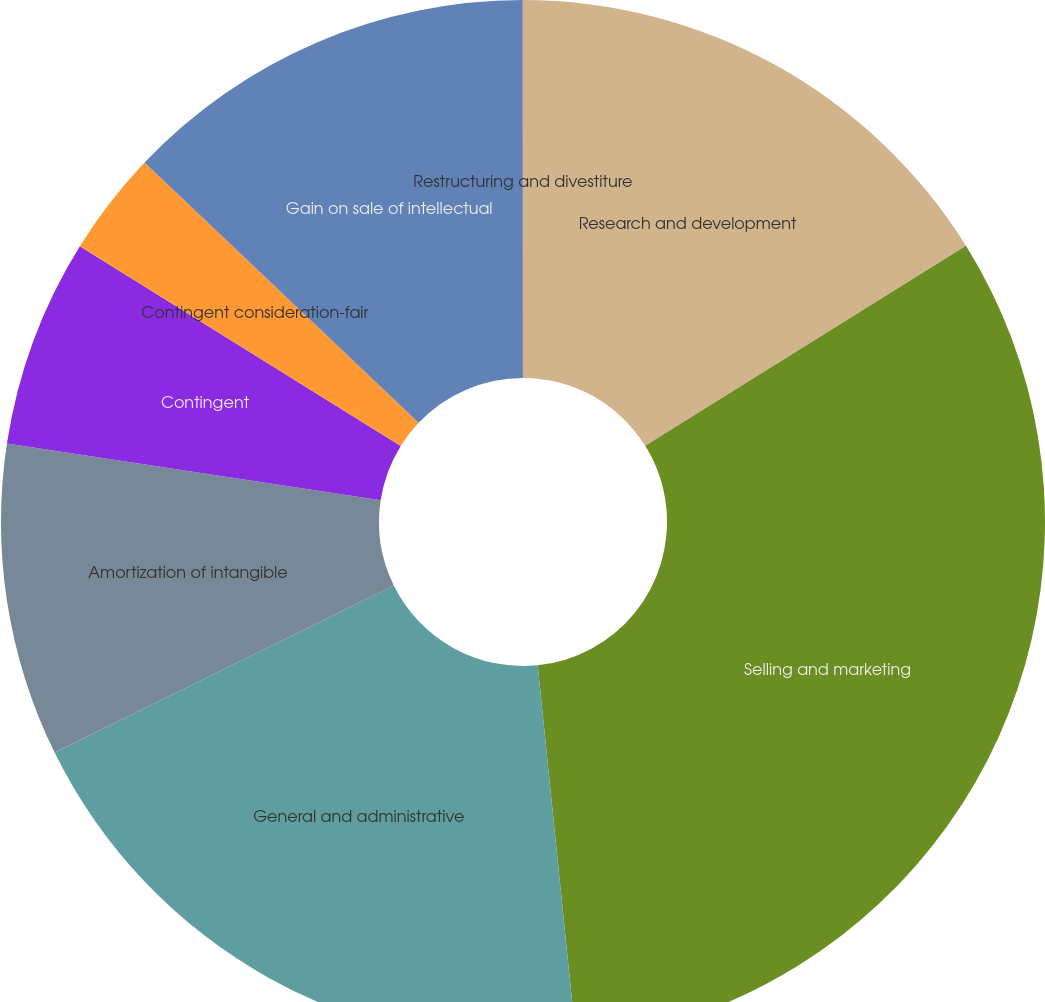Convert chart to OTSL. <chart><loc_0><loc_0><loc_500><loc_500><pie_chart><fcel>Research and development<fcel>Selling and marketing<fcel>General and administrative<fcel>Amortization of intangible<fcel>Contingent<fcel>Contingent consideration-fair<fcel>Gain on sale of intellectual<fcel>Restructuring and divestiture<nl><fcel>16.13%<fcel>32.25%<fcel>19.35%<fcel>9.68%<fcel>6.46%<fcel>3.23%<fcel>12.9%<fcel>0.01%<nl></chart> 